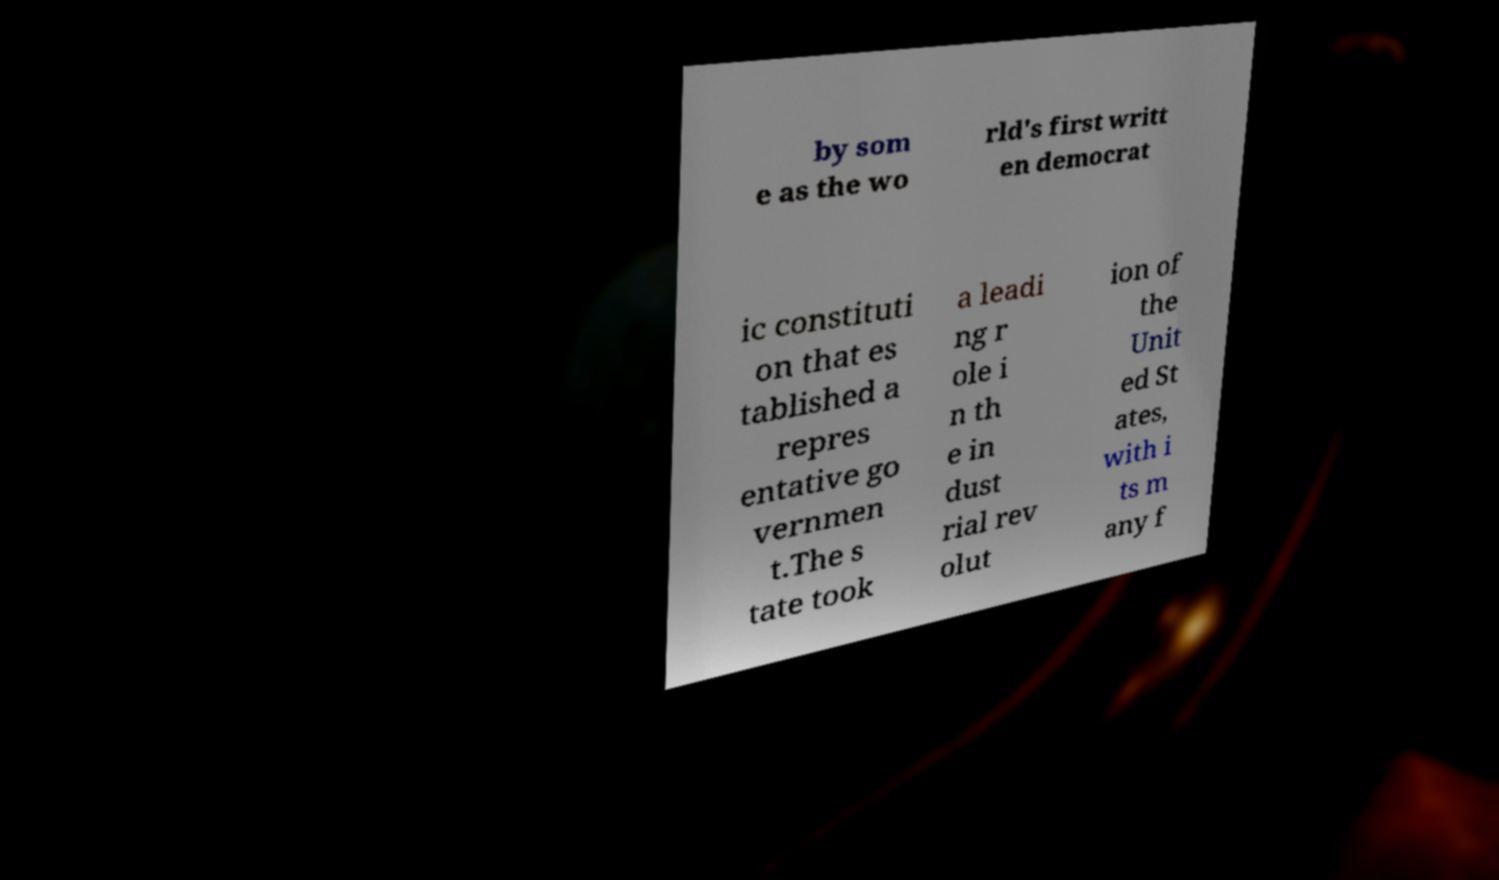Could you assist in decoding the text presented in this image and type it out clearly? by som e as the wo rld's first writt en democrat ic constituti on that es tablished a repres entative go vernmen t.The s tate took a leadi ng r ole i n th e in dust rial rev olut ion of the Unit ed St ates, with i ts m any f 